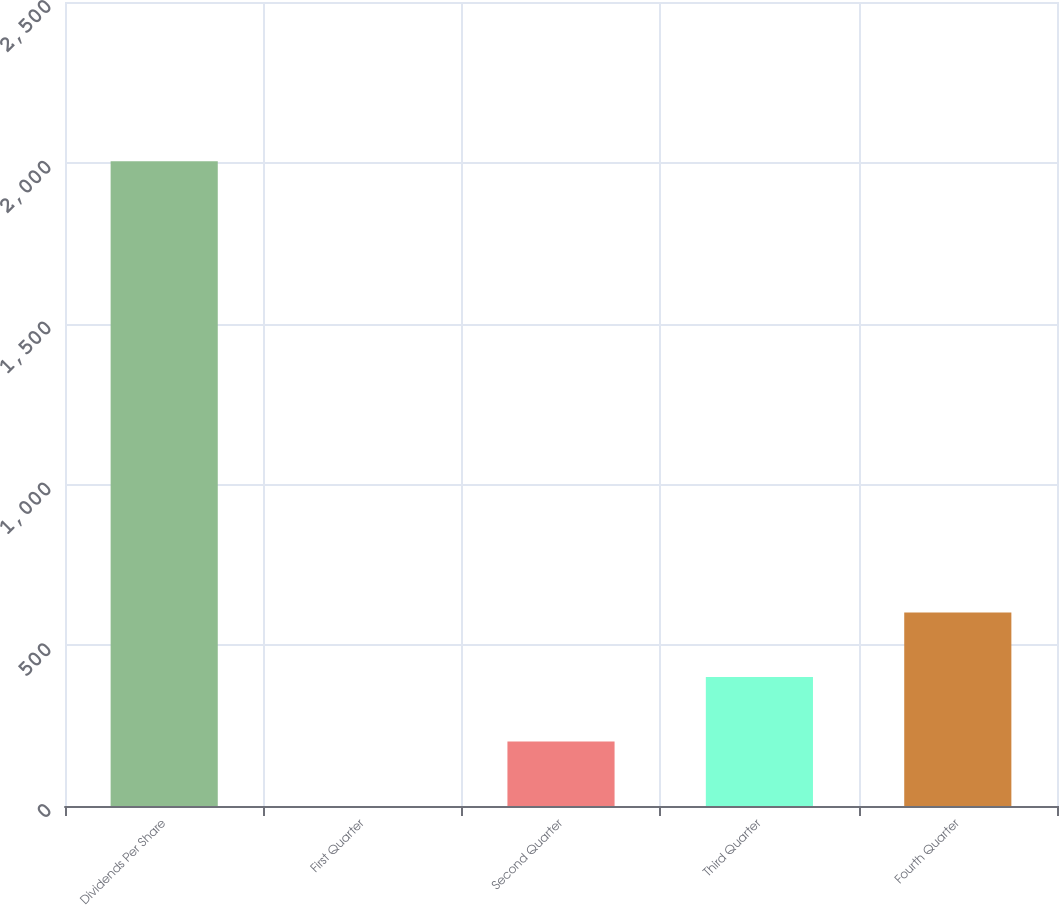<chart> <loc_0><loc_0><loc_500><loc_500><bar_chart><fcel>Dividends Per Share<fcel>First Quarter<fcel>Second Quarter<fcel>Third Quarter<fcel>Fourth Quarter<nl><fcel>2005<fcel>0.21<fcel>200.69<fcel>401.17<fcel>601.65<nl></chart> 